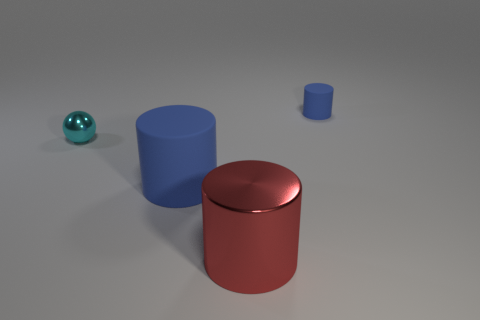Add 2 large metallic objects. How many objects exist? 6 Subtract all cylinders. How many objects are left? 1 Subtract all cyan objects. Subtract all small yellow matte balls. How many objects are left? 3 Add 2 blue rubber things. How many blue rubber things are left? 4 Add 3 tiny blue rubber things. How many tiny blue rubber things exist? 4 Subtract 0 green cylinders. How many objects are left? 4 